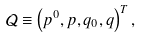Convert formula to latex. <formula><loc_0><loc_0><loc_500><loc_500>\mathcal { Q } \equiv \left ( p ^ { 0 } , p , q _ { 0 } , q \right ) ^ { T } ,</formula> 